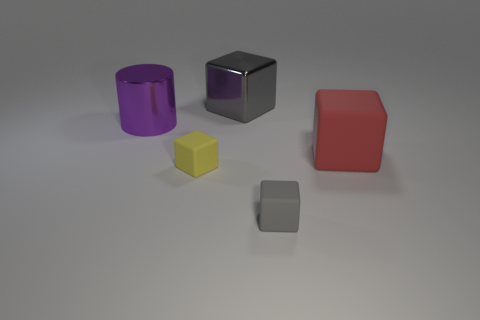What is the texture of the objects in the image? The objects appear to have a smooth, matte finish, with subtle reflections that suggest a soft lighting environment. 